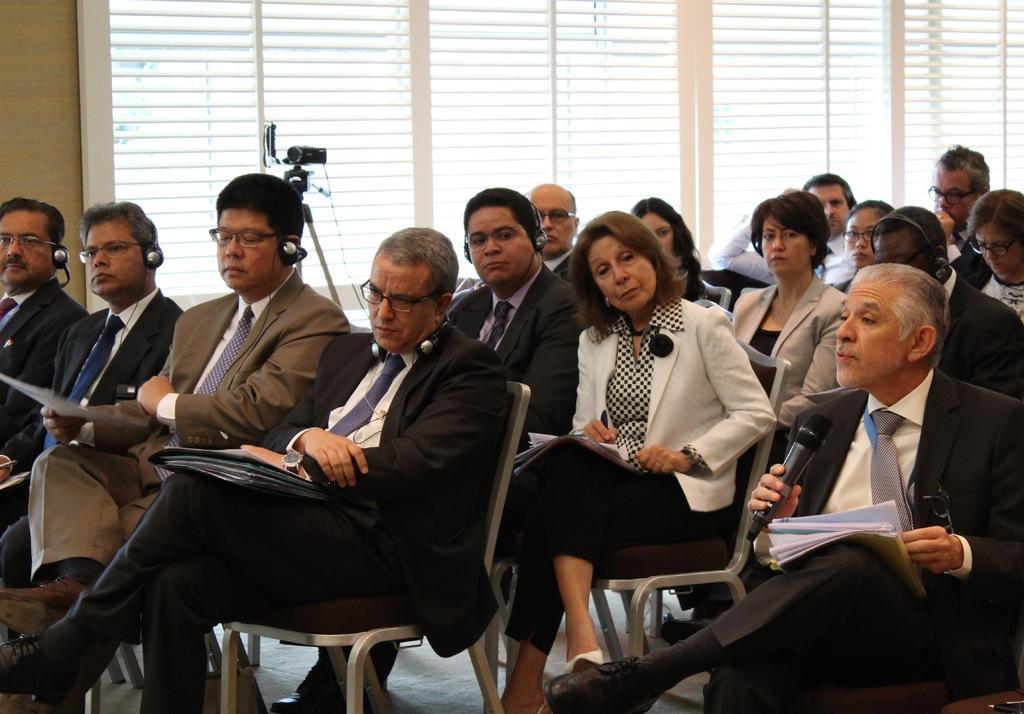How would you summarize this image in a sentence or two? In this image there are group of persons sitting. In the background there are windows and there is a camera. 